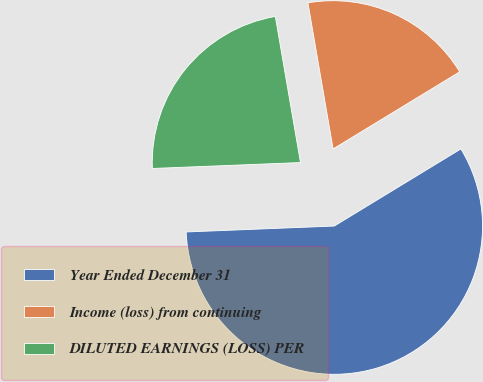Convert chart to OTSL. <chart><loc_0><loc_0><loc_500><loc_500><pie_chart><fcel>Year Ended December 31<fcel>Income (loss) from continuing<fcel>DILUTED EARNINGS (LOSS) PER<nl><fcel>58.07%<fcel>19.01%<fcel>22.92%<nl></chart> 